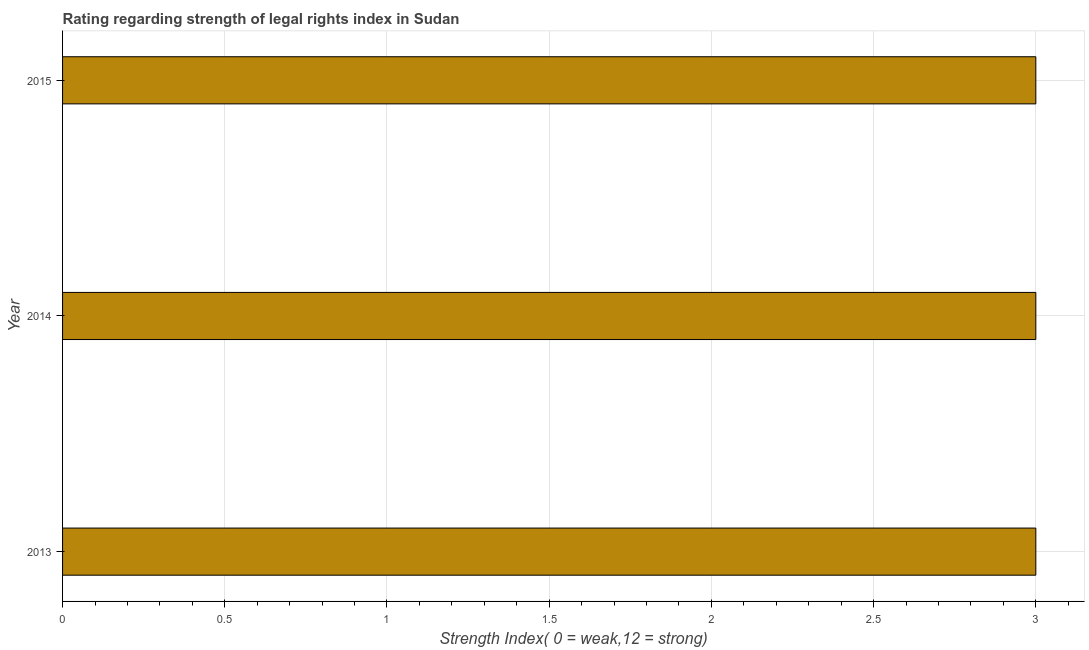What is the title of the graph?
Keep it short and to the point. Rating regarding strength of legal rights index in Sudan. What is the label or title of the X-axis?
Your response must be concise. Strength Index( 0 = weak,12 = strong). Across all years, what is the maximum strength of legal rights index?
Your answer should be very brief. 3. In which year was the strength of legal rights index maximum?
Ensure brevity in your answer.  2013. What is the sum of the strength of legal rights index?
Your response must be concise. 9. What is the difference between the strength of legal rights index in 2013 and 2015?
Your response must be concise. 0. What is the median strength of legal rights index?
Give a very brief answer. 3. In how many years, is the strength of legal rights index greater than 0.8 ?
Give a very brief answer. 3. Is the strength of legal rights index in 2013 less than that in 2014?
Make the answer very short. No. What is the difference between the highest and the second highest strength of legal rights index?
Keep it short and to the point. 0. What is the difference between the highest and the lowest strength of legal rights index?
Your response must be concise. 0. In how many years, is the strength of legal rights index greater than the average strength of legal rights index taken over all years?
Your answer should be very brief. 0. How many bars are there?
Offer a terse response. 3. Are all the bars in the graph horizontal?
Provide a short and direct response. Yes. How many years are there in the graph?
Offer a very short reply. 3. What is the difference between two consecutive major ticks on the X-axis?
Your answer should be very brief. 0.5. What is the Strength Index( 0 = weak,12 = strong) in 2014?
Your response must be concise. 3. What is the Strength Index( 0 = weak,12 = strong) of 2015?
Offer a terse response. 3. What is the difference between the Strength Index( 0 = weak,12 = strong) in 2013 and 2014?
Provide a succinct answer. 0. What is the difference between the Strength Index( 0 = weak,12 = strong) in 2013 and 2015?
Offer a terse response. 0. What is the difference between the Strength Index( 0 = weak,12 = strong) in 2014 and 2015?
Give a very brief answer. 0. What is the ratio of the Strength Index( 0 = weak,12 = strong) in 2013 to that in 2014?
Your response must be concise. 1. What is the ratio of the Strength Index( 0 = weak,12 = strong) in 2014 to that in 2015?
Keep it short and to the point. 1. 